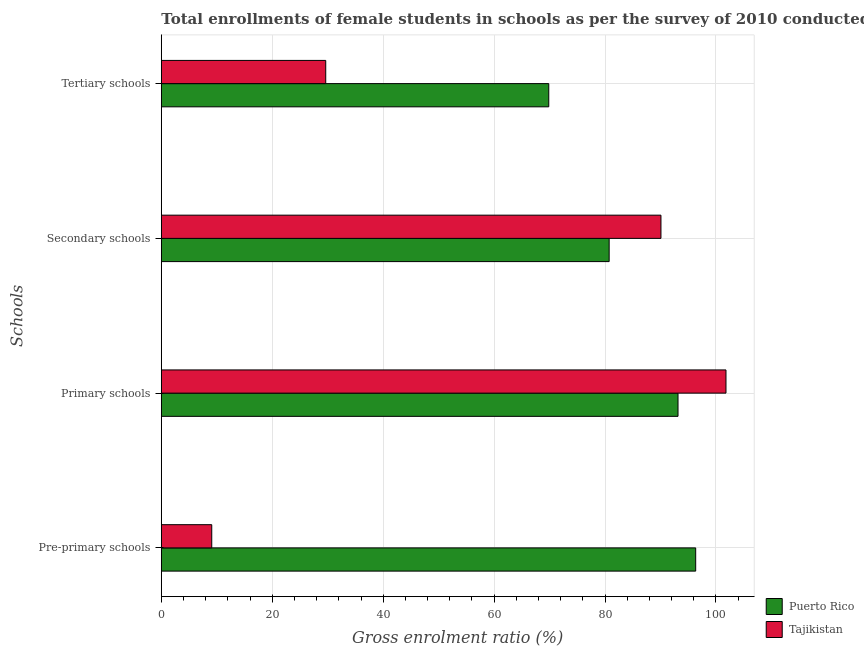Are the number of bars per tick equal to the number of legend labels?
Make the answer very short. Yes. How many bars are there on the 1st tick from the top?
Your answer should be very brief. 2. What is the label of the 1st group of bars from the top?
Offer a very short reply. Tertiary schools. What is the gross enrolment ratio(female) in secondary schools in Tajikistan?
Offer a very short reply. 90.08. Across all countries, what is the maximum gross enrolment ratio(female) in tertiary schools?
Your response must be concise. 69.85. Across all countries, what is the minimum gross enrolment ratio(female) in tertiary schools?
Your answer should be compact. 29.64. In which country was the gross enrolment ratio(female) in secondary schools maximum?
Make the answer very short. Tajikistan. In which country was the gross enrolment ratio(female) in tertiary schools minimum?
Make the answer very short. Tajikistan. What is the total gross enrolment ratio(female) in tertiary schools in the graph?
Provide a short and direct response. 99.49. What is the difference between the gross enrolment ratio(female) in tertiary schools in Puerto Rico and that in Tajikistan?
Offer a terse response. 40.21. What is the difference between the gross enrolment ratio(female) in pre-primary schools in Tajikistan and the gross enrolment ratio(female) in secondary schools in Puerto Rico?
Offer a terse response. -71.65. What is the average gross enrolment ratio(female) in secondary schools per country?
Give a very brief answer. 85.41. What is the difference between the gross enrolment ratio(female) in pre-primary schools and gross enrolment ratio(female) in secondary schools in Tajikistan?
Make the answer very short. -80.99. What is the ratio of the gross enrolment ratio(female) in tertiary schools in Tajikistan to that in Puerto Rico?
Ensure brevity in your answer.  0.42. Is the gross enrolment ratio(female) in pre-primary schools in Puerto Rico less than that in Tajikistan?
Give a very brief answer. No. What is the difference between the highest and the second highest gross enrolment ratio(female) in primary schools?
Make the answer very short. 8.65. What is the difference between the highest and the lowest gross enrolment ratio(female) in tertiary schools?
Your response must be concise. 40.21. In how many countries, is the gross enrolment ratio(female) in secondary schools greater than the average gross enrolment ratio(female) in secondary schools taken over all countries?
Keep it short and to the point. 1. Is the sum of the gross enrolment ratio(female) in pre-primary schools in Tajikistan and Puerto Rico greater than the maximum gross enrolment ratio(female) in primary schools across all countries?
Ensure brevity in your answer.  Yes. What does the 2nd bar from the top in Primary schools represents?
Your response must be concise. Puerto Rico. What does the 2nd bar from the bottom in Pre-primary schools represents?
Keep it short and to the point. Tajikistan. How many bars are there?
Give a very brief answer. 8. Are all the bars in the graph horizontal?
Provide a succinct answer. Yes. How many countries are there in the graph?
Keep it short and to the point. 2. Does the graph contain any zero values?
Your answer should be very brief. No. Does the graph contain grids?
Keep it short and to the point. Yes. Where does the legend appear in the graph?
Your response must be concise. Bottom right. What is the title of the graph?
Give a very brief answer. Total enrollments of female students in schools as per the survey of 2010 conducted in different countries. What is the label or title of the Y-axis?
Give a very brief answer. Schools. What is the Gross enrolment ratio (%) in Puerto Rico in Pre-primary schools?
Provide a succinct answer. 96.34. What is the Gross enrolment ratio (%) in Tajikistan in Pre-primary schools?
Your answer should be compact. 9.09. What is the Gross enrolment ratio (%) of Puerto Rico in Primary schools?
Make the answer very short. 93.15. What is the Gross enrolment ratio (%) in Tajikistan in Primary schools?
Ensure brevity in your answer.  101.8. What is the Gross enrolment ratio (%) of Puerto Rico in Secondary schools?
Your response must be concise. 80.74. What is the Gross enrolment ratio (%) of Tajikistan in Secondary schools?
Make the answer very short. 90.08. What is the Gross enrolment ratio (%) in Puerto Rico in Tertiary schools?
Provide a succinct answer. 69.85. What is the Gross enrolment ratio (%) of Tajikistan in Tertiary schools?
Your response must be concise. 29.64. Across all Schools, what is the maximum Gross enrolment ratio (%) in Puerto Rico?
Give a very brief answer. 96.34. Across all Schools, what is the maximum Gross enrolment ratio (%) in Tajikistan?
Your answer should be very brief. 101.8. Across all Schools, what is the minimum Gross enrolment ratio (%) of Puerto Rico?
Make the answer very short. 69.85. Across all Schools, what is the minimum Gross enrolment ratio (%) in Tajikistan?
Make the answer very short. 9.09. What is the total Gross enrolment ratio (%) in Puerto Rico in the graph?
Your answer should be very brief. 340.08. What is the total Gross enrolment ratio (%) in Tajikistan in the graph?
Your answer should be very brief. 230.61. What is the difference between the Gross enrolment ratio (%) of Puerto Rico in Pre-primary schools and that in Primary schools?
Give a very brief answer. 3.18. What is the difference between the Gross enrolment ratio (%) of Tajikistan in Pre-primary schools and that in Primary schools?
Keep it short and to the point. -92.71. What is the difference between the Gross enrolment ratio (%) of Puerto Rico in Pre-primary schools and that in Secondary schools?
Your answer should be compact. 15.6. What is the difference between the Gross enrolment ratio (%) of Tajikistan in Pre-primary schools and that in Secondary schools?
Offer a terse response. -80.99. What is the difference between the Gross enrolment ratio (%) of Puerto Rico in Pre-primary schools and that in Tertiary schools?
Keep it short and to the point. 26.49. What is the difference between the Gross enrolment ratio (%) in Tajikistan in Pre-primary schools and that in Tertiary schools?
Give a very brief answer. -20.55. What is the difference between the Gross enrolment ratio (%) of Puerto Rico in Primary schools and that in Secondary schools?
Keep it short and to the point. 12.41. What is the difference between the Gross enrolment ratio (%) in Tajikistan in Primary schools and that in Secondary schools?
Your answer should be compact. 11.72. What is the difference between the Gross enrolment ratio (%) in Puerto Rico in Primary schools and that in Tertiary schools?
Offer a terse response. 23.3. What is the difference between the Gross enrolment ratio (%) in Tajikistan in Primary schools and that in Tertiary schools?
Provide a succinct answer. 72.16. What is the difference between the Gross enrolment ratio (%) of Puerto Rico in Secondary schools and that in Tertiary schools?
Offer a very short reply. 10.89. What is the difference between the Gross enrolment ratio (%) of Tajikistan in Secondary schools and that in Tertiary schools?
Your answer should be compact. 60.44. What is the difference between the Gross enrolment ratio (%) in Puerto Rico in Pre-primary schools and the Gross enrolment ratio (%) in Tajikistan in Primary schools?
Your answer should be compact. -5.46. What is the difference between the Gross enrolment ratio (%) of Puerto Rico in Pre-primary schools and the Gross enrolment ratio (%) of Tajikistan in Secondary schools?
Your answer should be very brief. 6.26. What is the difference between the Gross enrolment ratio (%) in Puerto Rico in Pre-primary schools and the Gross enrolment ratio (%) in Tajikistan in Tertiary schools?
Make the answer very short. 66.7. What is the difference between the Gross enrolment ratio (%) of Puerto Rico in Primary schools and the Gross enrolment ratio (%) of Tajikistan in Secondary schools?
Offer a terse response. 3.08. What is the difference between the Gross enrolment ratio (%) of Puerto Rico in Primary schools and the Gross enrolment ratio (%) of Tajikistan in Tertiary schools?
Provide a succinct answer. 63.51. What is the difference between the Gross enrolment ratio (%) in Puerto Rico in Secondary schools and the Gross enrolment ratio (%) in Tajikistan in Tertiary schools?
Provide a short and direct response. 51.1. What is the average Gross enrolment ratio (%) of Puerto Rico per Schools?
Keep it short and to the point. 85.02. What is the average Gross enrolment ratio (%) of Tajikistan per Schools?
Make the answer very short. 57.65. What is the difference between the Gross enrolment ratio (%) of Puerto Rico and Gross enrolment ratio (%) of Tajikistan in Pre-primary schools?
Give a very brief answer. 87.25. What is the difference between the Gross enrolment ratio (%) of Puerto Rico and Gross enrolment ratio (%) of Tajikistan in Primary schools?
Your response must be concise. -8.65. What is the difference between the Gross enrolment ratio (%) in Puerto Rico and Gross enrolment ratio (%) in Tajikistan in Secondary schools?
Your response must be concise. -9.34. What is the difference between the Gross enrolment ratio (%) in Puerto Rico and Gross enrolment ratio (%) in Tajikistan in Tertiary schools?
Provide a short and direct response. 40.21. What is the ratio of the Gross enrolment ratio (%) in Puerto Rico in Pre-primary schools to that in Primary schools?
Your response must be concise. 1.03. What is the ratio of the Gross enrolment ratio (%) of Tajikistan in Pre-primary schools to that in Primary schools?
Your answer should be very brief. 0.09. What is the ratio of the Gross enrolment ratio (%) in Puerto Rico in Pre-primary schools to that in Secondary schools?
Provide a succinct answer. 1.19. What is the ratio of the Gross enrolment ratio (%) of Tajikistan in Pre-primary schools to that in Secondary schools?
Offer a terse response. 0.1. What is the ratio of the Gross enrolment ratio (%) in Puerto Rico in Pre-primary schools to that in Tertiary schools?
Ensure brevity in your answer.  1.38. What is the ratio of the Gross enrolment ratio (%) in Tajikistan in Pre-primary schools to that in Tertiary schools?
Your answer should be very brief. 0.31. What is the ratio of the Gross enrolment ratio (%) of Puerto Rico in Primary schools to that in Secondary schools?
Offer a terse response. 1.15. What is the ratio of the Gross enrolment ratio (%) of Tajikistan in Primary schools to that in Secondary schools?
Your answer should be very brief. 1.13. What is the ratio of the Gross enrolment ratio (%) in Puerto Rico in Primary schools to that in Tertiary schools?
Your answer should be compact. 1.33. What is the ratio of the Gross enrolment ratio (%) of Tajikistan in Primary schools to that in Tertiary schools?
Your response must be concise. 3.43. What is the ratio of the Gross enrolment ratio (%) of Puerto Rico in Secondary schools to that in Tertiary schools?
Keep it short and to the point. 1.16. What is the ratio of the Gross enrolment ratio (%) of Tajikistan in Secondary schools to that in Tertiary schools?
Provide a short and direct response. 3.04. What is the difference between the highest and the second highest Gross enrolment ratio (%) in Puerto Rico?
Keep it short and to the point. 3.18. What is the difference between the highest and the second highest Gross enrolment ratio (%) of Tajikistan?
Your answer should be compact. 11.72. What is the difference between the highest and the lowest Gross enrolment ratio (%) of Puerto Rico?
Ensure brevity in your answer.  26.49. What is the difference between the highest and the lowest Gross enrolment ratio (%) of Tajikistan?
Your answer should be compact. 92.71. 